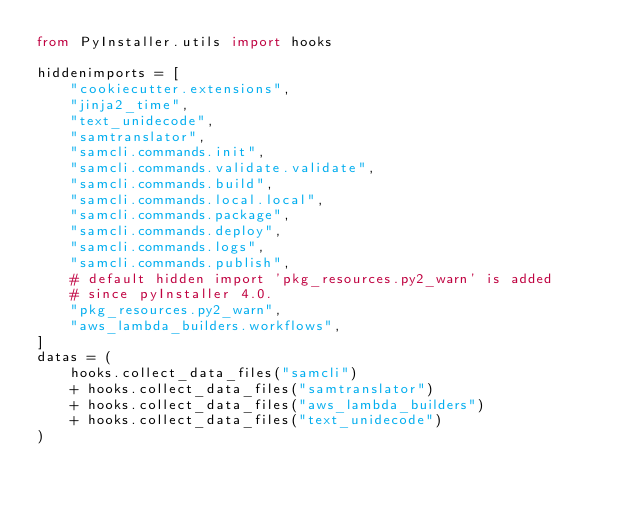<code> <loc_0><loc_0><loc_500><loc_500><_Python_>from PyInstaller.utils import hooks

hiddenimports = [
    "cookiecutter.extensions",
    "jinja2_time",
    "text_unidecode",
    "samtranslator",
    "samcli.commands.init",
    "samcli.commands.validate.validate",
    "samcli.commands.build",
    "samcli.commands.local.local",
    "samcli.commands.package",
    "samcli.commands.deploy",
    "samcli.commands.logs",
    "samcli.commands.publish",
    # default hidden import 'pkg_resources.py2_warn' is added
    # since pyInstaller 4.0.
    "pkg_resources.py2_warn",
    "aws_lambda_builders.workflows",
]
datas = (
    hooks.collect_data_files("samcli")
    + hooks.collect_data_files("samtranslator")
    + hooks.collect_data_files("aws_lambda_builders")
    + hooks.collect_data_files("text_unidecode")
)
</code> 